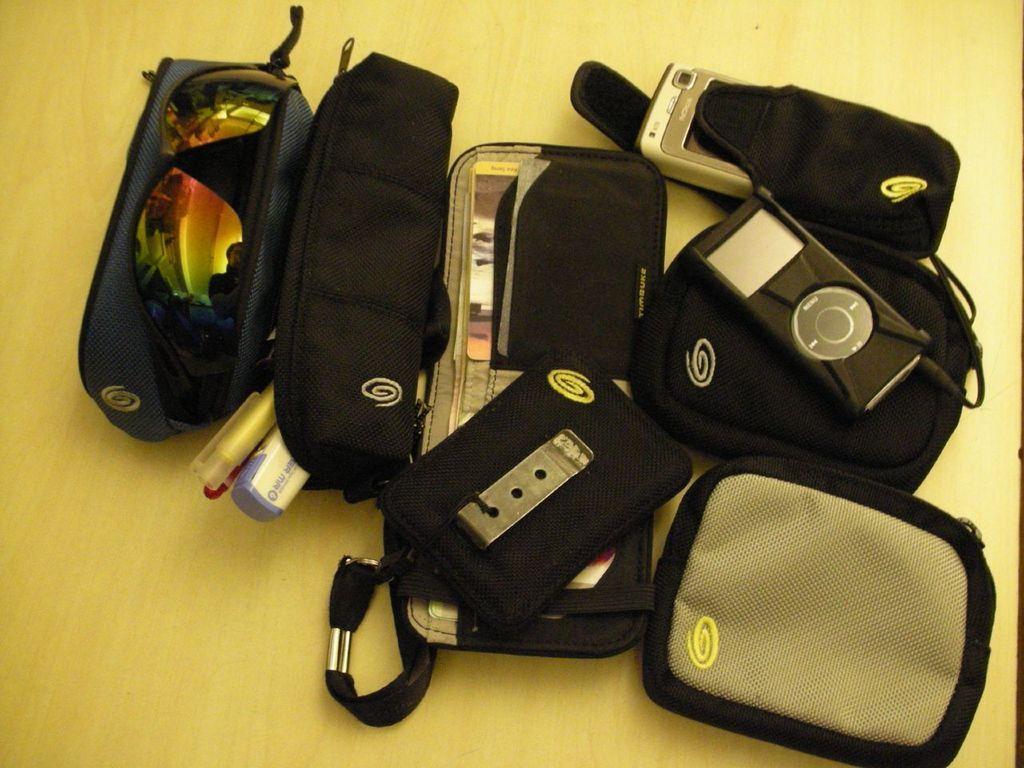Please provide a concise description of this image. At the bottom of the image there is a table, on the table there are some boxes and bags and glasses and there are some electronic devices. 